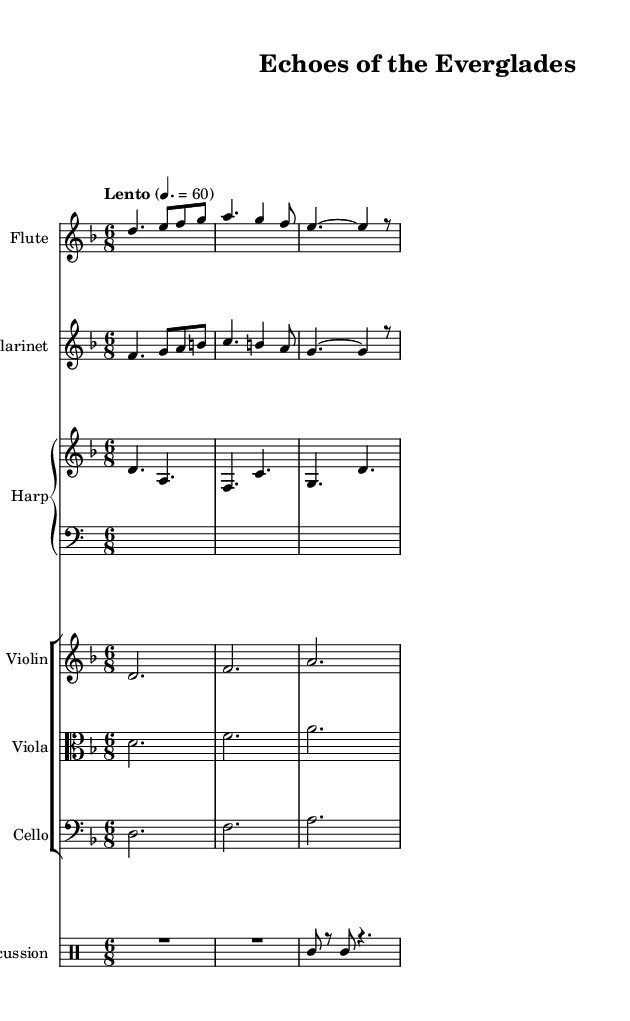What is the key signature of this music? The key signature is D minor, which has one flat (B flat). This can be determined by looking at the key signature indicated at the beginning of the sheet music.
Answer: D minor What is the time signature of this music? The time signature is 6/8, which is shown at the beginning of the sheet music. This indicates that there are six eighth-note beats in each measure.
Answer: 6/8 What is the tempo indication for the piece? The tempo indication is "Lento" with a quarter note equals 60, meaning it should be played slowly at a rate of 60 beats per minute. This is found in the tempo marking near the beginning.
Answer: Lento How many instruments are featured in this piece? There are six instruments featured: flute, clarinet, harp, violin, viola, cello, and percussion. Each instrument is clearly labeled and part of a different staff or staff group.
Answer: Six Which instruments are part of the string section? The string section consists of the violin, viola, and cello, evidenced by their grouping together in a staff group labeled appropriately in the music.
Answer: Violin, viola, cello What rhythmic style is seen in the percussion part? The percussion part primarily uses rests and single note hits, which creates an ambient effect. The long rests (R2) contribute to the spacious feeling of the soundscape.
Answer: Ambient effect Which two instruments share the same melodic material in this piece? The flute and clarinet share similar melodic material, as evidenced by their respective lines closely following one another in pitch and rhythm throughout the piece.
Answer: Flute and clarinet 